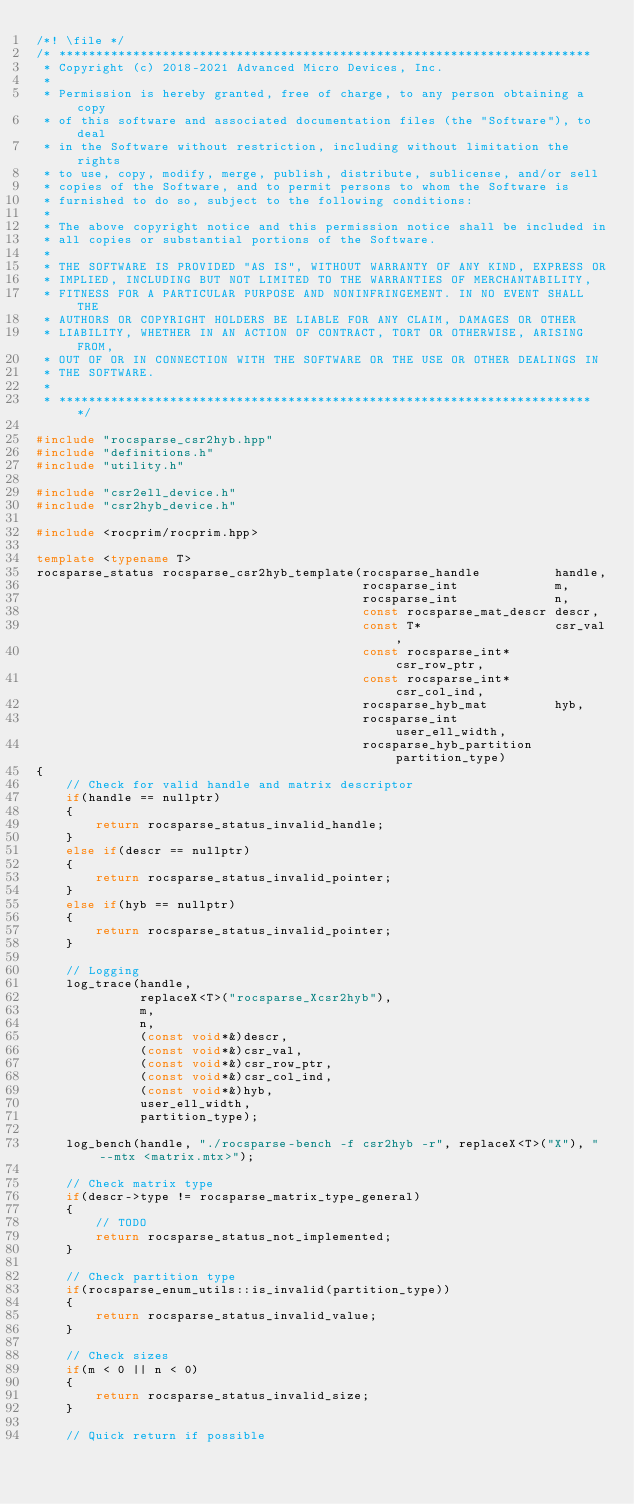Convert code to text. <code><loc_0><loc_0><loc_500><loc_500><_C++_>/*! \file */
/* ************************************************************************
 * Copyright (c) 2018-2021 Advanced Micro Devices, Inc.
 *
 * Permission is hereby granted, free of charge, to any person obtaining a copy
 * of this software and associated documentation files (the "Software"), to deal
 * in the Software without restriction, including without limitation the rights
 * to use, copy, modify, merge, publish, distribute, sublicense, and/or sell
 * copies of the Software, and to permit persons to whom the Software is
 * furnished to do so, subject to the following conditions:
 *
 * The above copyright notice and this permission notice shall be included in
 * all copies or substantial portions of the Software.
 *
 * THE SOFTWARE IS PROVIDED "AS IS", WITHOUT WARRANTY OF ANY KIND, EXPRESS OR
 * IMPLIED, INCLUDING BUT NOT LIMITED TO THE WARRANTIES OF MERCHANTABILITY,
 * FITNESS FOR A PARTICULAR PURPOSE AND NONINFRINGEMENT. IN NO EVENT SHALL THE
 * AUTHORS OR COPYRIGHT HOLDERS BE LIABLE FOR ANY CLAIM, DAMAGES OR OTHER
 * LIABILITY, WHETHER IN AN ACTION OF CONTRACT, TORT OR OTHERWISE, ARISING FROM,
 * OUT OF OR IN CONNECTION WITH THE SOFTWARE OR THE USE OR OTHER DEALINGS IN
 * THE SOFTWARE.
 *
 * ************************************************************************ */

#include "rocsparse_csr2hyb.hpp"
#include "definitions.h"
#include "utility.h"

#include "csr2ell_device.h"
#include "csr2hyb_device.h"

#include <rocprim/rocprim.hpp>

template <typename T>
rocsparse_status rocsparse_csr2hyb_template(rocsparse_handle          handle,
                                            rocsparse_int             m,
                                            rocsparse_int             n,
                                            const rocsparse_mat_descr descr,
                                            const T*                  csr_val,
                                            const rocsparse_int*      csr_row_ptr,
                                            const rocsparse_int*      csr_col_ind,
                                            rocsparse_hyb_mat         hyb,
                                            rocsparse_int             user_ell_width,
                                            rocsparse_hyb_partition   partition_type)
{
    // Check for valid handle and matrix descriptor
    if(handle == nullptr)
    {
        return rocsparse_status_invalid_handle;
    }
    else if(descr == nullptr)
    {
        return rocsparse_status_invalid_pointer;
    }
    else if(hyb == nullptr)
    {
        return rocsparse_status_invalid_pointer;
    }

    // Logging
    log_trace(handle,
              replaceX<T>("rocsparse_Xcsr2hyb"),
              m,
              n,
              (const void*&)descr,
              (const void*&)csr_val,
              (const void*&)csr_row_ptr,
              (const void*&)csr_col_ind,
              (const void*&)hyb,
              user_ell_width,
              partition_type);

    log_bench(handle, "./rocsparse-bench -f csr2hyb -r", replaceX<T>("X"), "--mtx <matrix.mtx>");

    // Check matrix type
    if(descr->type != rocsparse_matrix_type_general)
    {
        // TODO
        return rocsparse_status_not_implemented;
    }

    // Check partition type
    if(rocsparse_enum_utils::is_invalid(partition_type))
    {
        return rocsparse_status_invalid_value;
    }

    // Check sizes
    if(m < 0 || n < 0)
    {
        return rocsparse_status_invalid_size;
    }

    // Quick return if possible</code> 